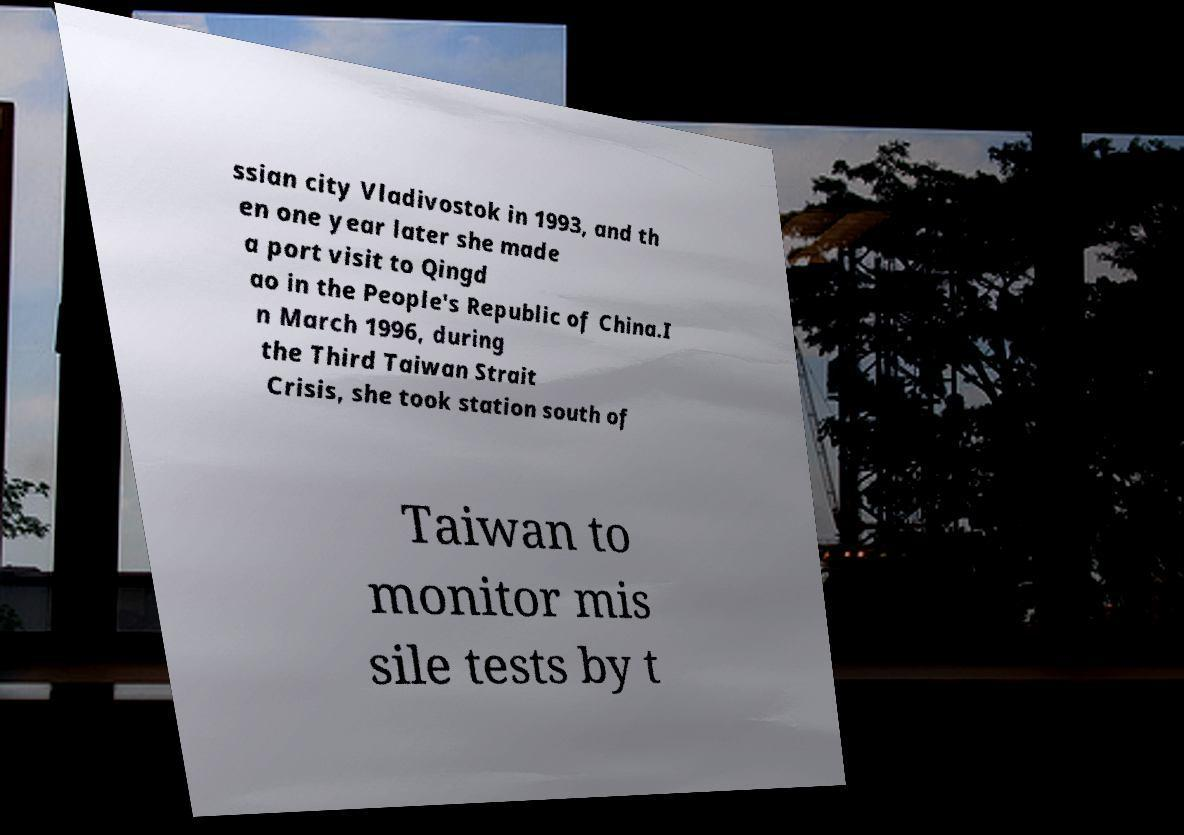For documentation purposes, I need the text within this image transcribed. Could you provide that? ssian city Vladivostok in 1993, and th en one year later she made a port visit to Qingd ao in the People's Republic of China.I n March 1996, during the Third Taiwan Strait Crisis, she took station south of Taiwan to monitor mis sile tests by t 